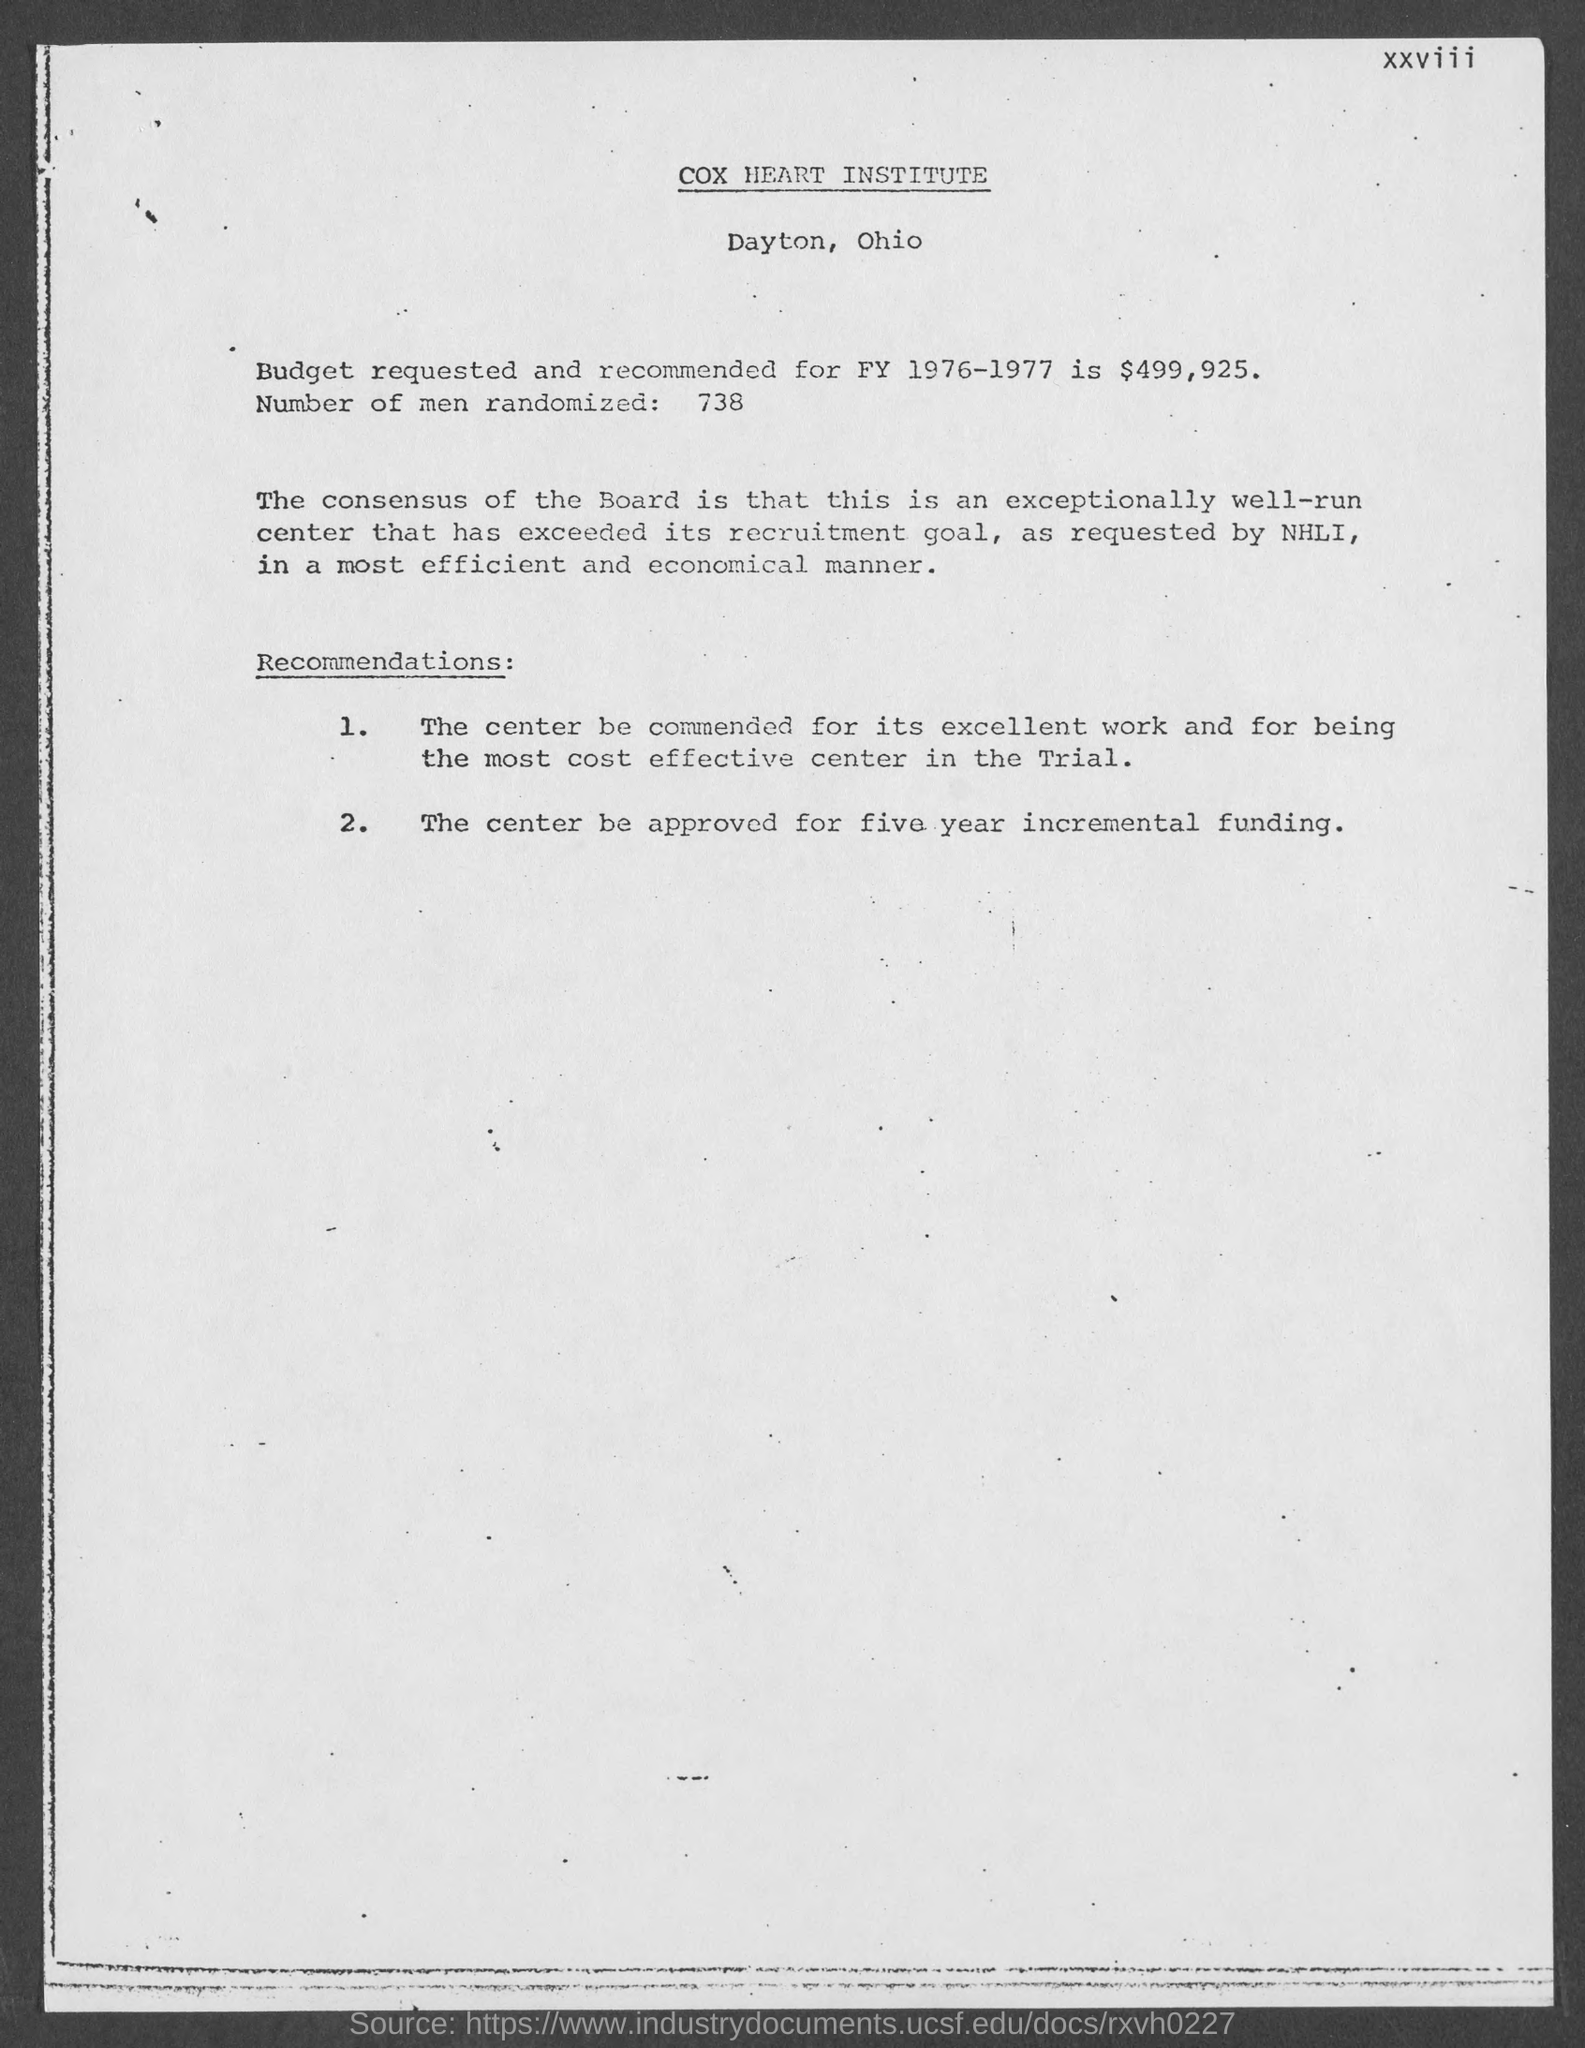What is the name of the institute ?
Your response must be concise. Cox heart institute. How many number of  men are randomized ?
Offer a terse response. 738. What is the amount of budget requested and recommended for fy 1976-1977 ?
Offer a very short reply. $499,925. What is the address of cox heart institute ?
Offer a very short reply. Dayton, Ohio. 